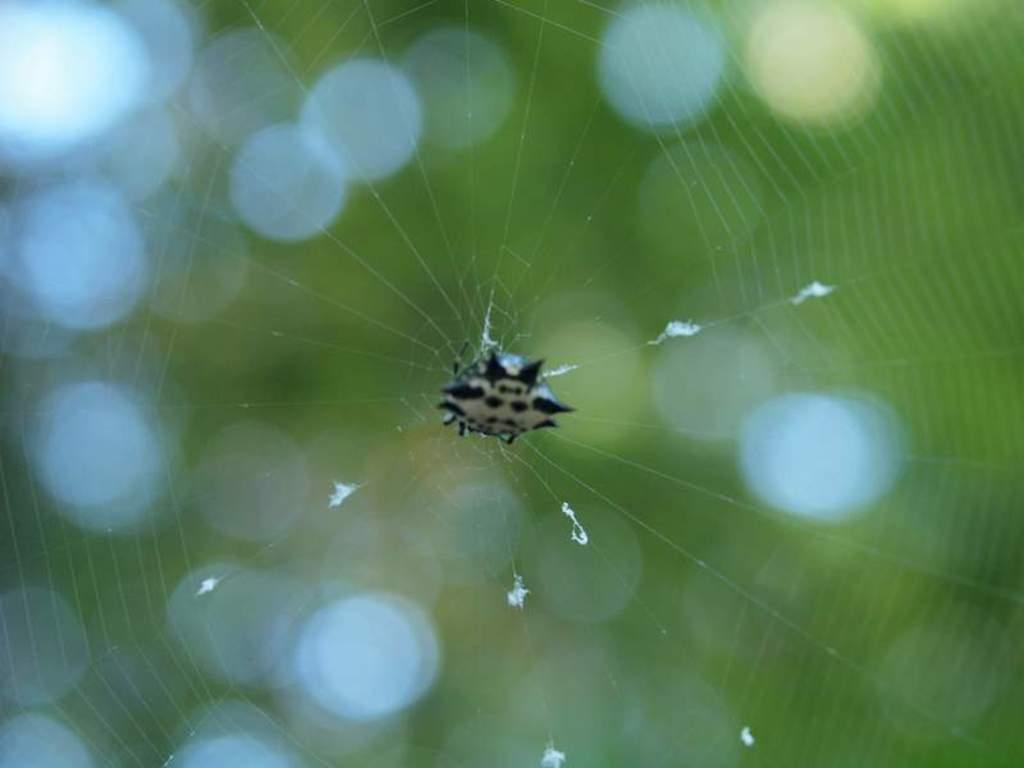What type of creature is in the image? There is an insect in the image. image. Where is the insect located? The insect is on a spider web. What type of kitten is waving the flag during the competition in the image? There is no kitten, flag, or competition present in the image; it features an insect on a spider web. 